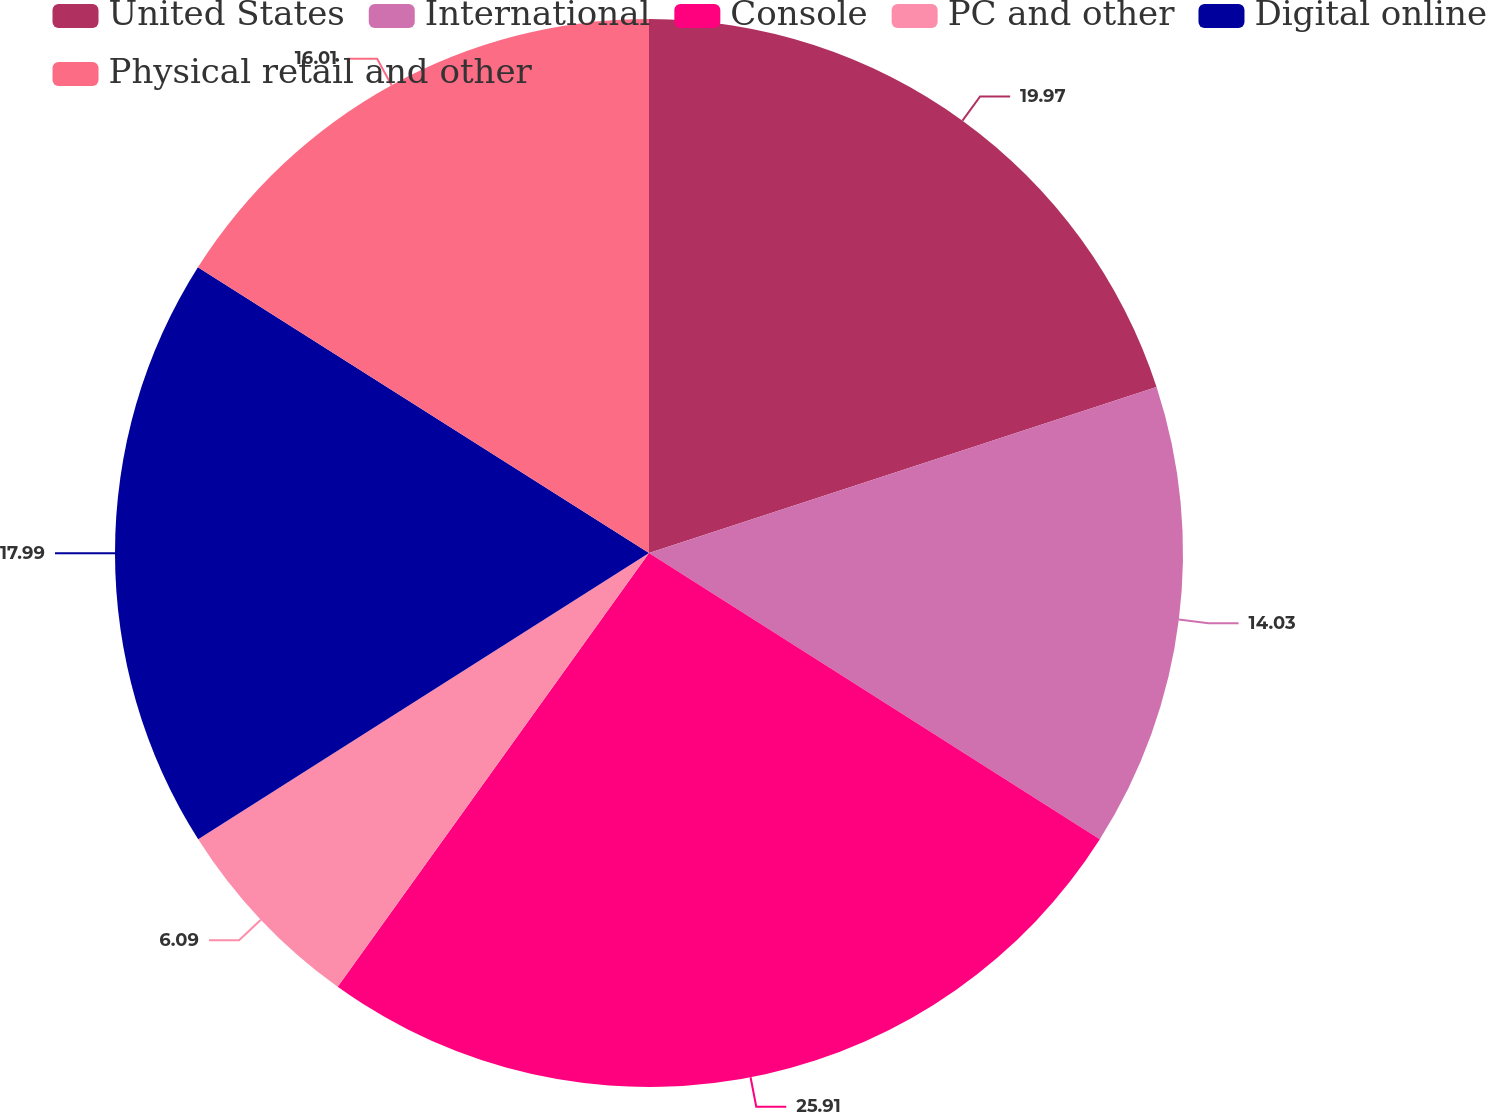Convert chart. <chart><loc_0><loc_0><loc_500><loc_500><pie_chart><fcel>United States<fcel>International<fcel>Console<fcel>PC and other<fcel>Digital online<fcel>Physical retail and other<nl><fcel>19.97%<fcel>14.03%<fcel>25.9%<fcel>6.09%<fcel>17.99%<fcel>16.01%<nl></chart> 